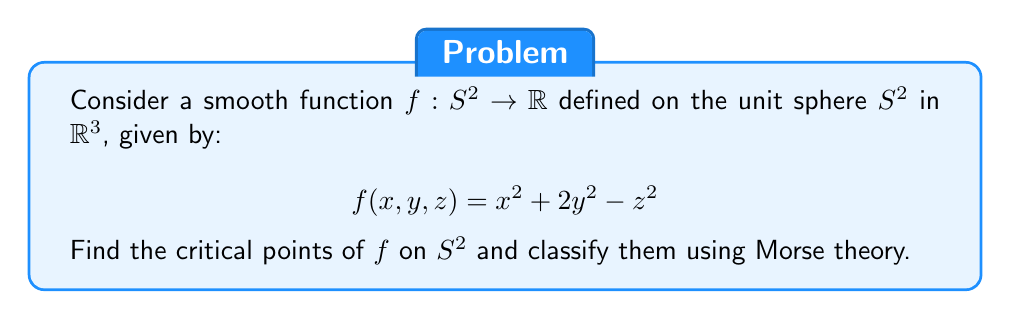Can you solve this math problem? To solve this problem, we'll follow these steps:

1) First, we need to understand that the unit sphere $S^2$ is defined by the constraint $x^2 + y^2 + z^2 = 1$.

2) To find critical points, we'll use the method of Lagrange multipliers. Let's define:

   $$L(x, y, z, \lambda) = f(x, y, z) - \lambda(x^2 + y^2 + z^2 - 1)$$

3) The critical points are where the gradient of $L$ is zero:

   $$\frac{\partial L}{\partial x} = 2x - 2\lambda x = 0$$
   $$\frac{\partial L}{\partial y} = 4y - 2\lambda y = 0$$
   $$\frac{\partial L}{\partial z} = -2z - 2\lambda z = 0$$
   $$\frac{\partial L}{\partial \lambda} = x^2 + y^2 + z^2 - 1 = 0$$

4) From these equations, we can deduce:
   - If $x \neq 0$, then $\lambda = 1$
   - If $y \neq 0$, then $\lambda = 2$
   - If $z \neq 0$, then $\lambda = -1$

5) This gives us three possible cases:
   a) $\lambda = 1$: $y = 0$, $z = 0$, $x = \pm 1$
   b) $\lambda = 2$: $x = 0$, $z = 0$, $y = \pm 1$
   c) $\lambda = -1$: $x = 0$, $y = 0$, $z = \pm 1$

6) To classify these critical points, we need to compute the Hessian of $f$ restricted to $S^2$. In local coordinates $(\theta, \phi)$, this is given by:

   $$H = \begin{pmatrix}
   \frac{\partial^2 f}{\partial \theta^2} & \frac{\partial^2 f}{\partial \theta \partial \phi} \\
   \frac{\partial^2 f}{\partial \phi \partial \theta} & \frac{\partial^2 f}{\partial \phi^2}
   \end{pmatrix}$$

7) Computing this at each critical point:
   - At $(\pm 1, 0, 0)$: $H = \begin{pmatrix} 1 & 0 \\ 0 & 3 \end{pmatrix}$, positive definite (local minimum)
   - At $(0, \pm 1, 0)$: $H = \begin{pmatrix} -1 & 0 \\ 0 & 3 \end{pmatrix}$, indefinite (saddle point)
   - At $(0, 0, \pm 1)$: $H = \begin{pmatrix} 3 & 0 \\ 0 & 1 \end{pmatrix}$, positive definite (local maximum)

8) By Morse theory, the Morse index of a critical point is the number of negative eigenvalues of the Hessian. So:
   - $(\pm 1, 0, 0)$ have Morse index 0 (local minima)
   - $(0, \pm 1, 0)$ have Morse index 1 (saddle points)
   - $(0, 0, \pm 1)$ have Morse index 2 (local maxima)
Answer: The critical points of $f$ on $S^2$ are:
- $(\pm 1, 0, 0)$: local minima (Morse index 0)
- $(0, \pm 1, 0)$: saddle points (Morse index 1)
- $(0, 0, \pm 1)$: local maxima (Morse index 2) 